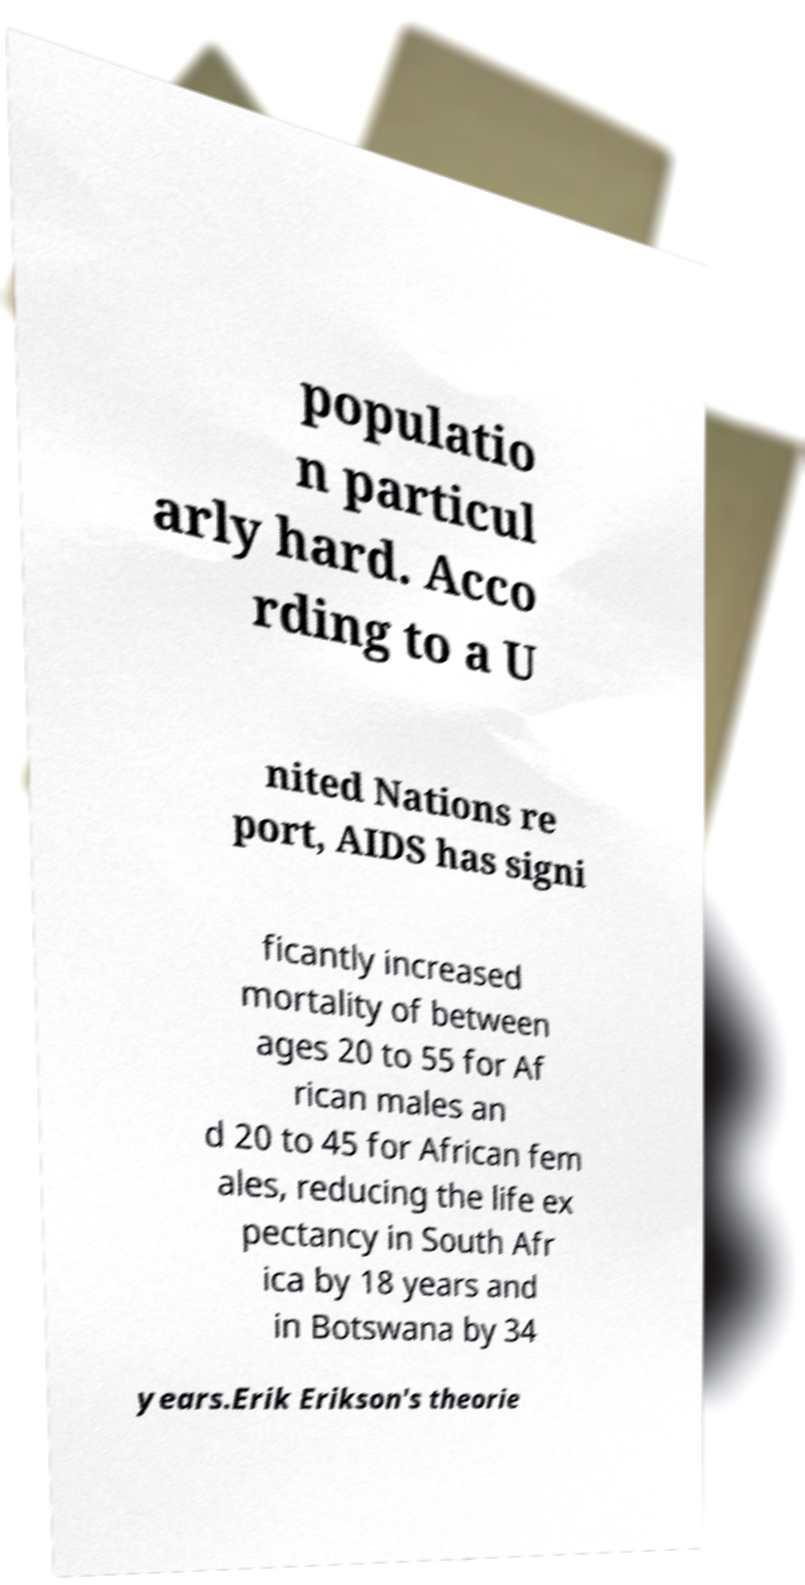Please identify and transcribe the text found in this image. populatio n particul arly hard. Acco rding to a U nited Nations re port, AIDS has signi ficantly increased mortality of between ages 20 to 55 for Af rican males an d 20 to 45 for African fem ales, reducing the life ex pectancy in South Afr ica by 18 years and in Botswana by 34 years.Erik Erikson's theorie 